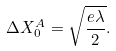Convert formula to latex. <formula><loc_0><loc_0><loc_500><loc_500>\Delta X ^ { A } _ { 0 } = \sqrt { \frac { e \lambda } { 2 } } .</formula> 